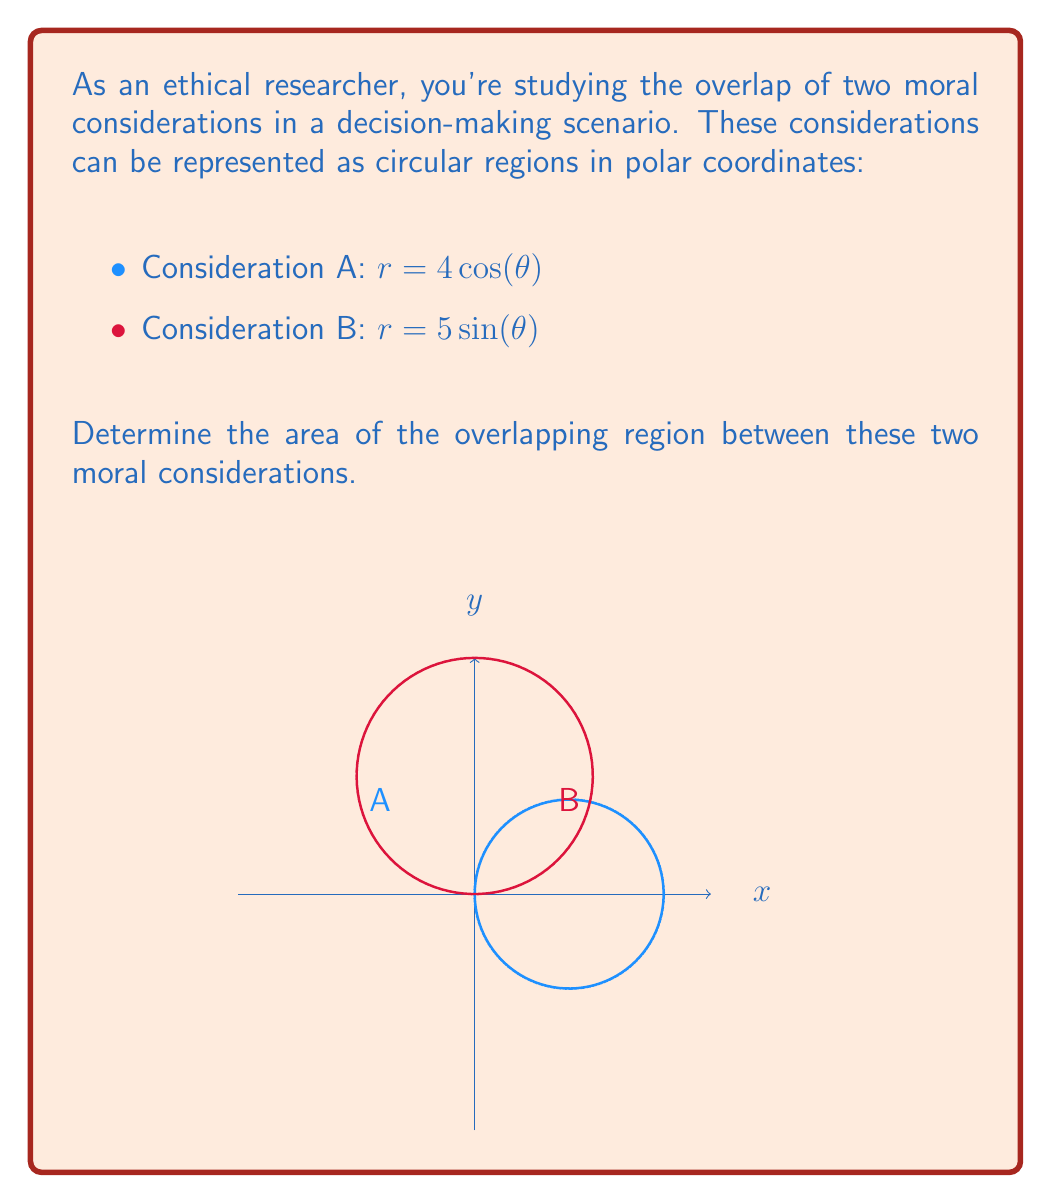Can you solve this math problem? To solve this problem, we'll follow these steps:

1) First, we need to find the points of intersection between the two curves. We can do this by equating the two equations:

   $4\cos(\theta) = 5\sin(\theta)$

2) Dividing both sides by $\cos(\theta)$:

   $4 = 5\tan(\theta)$

3) Solving for $\theta$:

   $\theta = \arctan(\frac{4}{5}) \approx 0.6747$ radians

4) Due to symmetry, the other intersection point is at $\pi - 0.6747 \approx 2.4669$ radians

5) The area of the overlapping region can be calculated using the formula:

   $A = \frac{1}{2}\int_{\theta_1}^{\theta_2} [r_2^2(\theta) - r_1^2(\theta)] d\theta$

   Where $r_2(\theta)$ is the larger radius and $r_1(\theta)$ is the smaller radius in the overlapping region.

6) In our case:

   $A = \frac{1}{2}\int_{0.6747}^{2.4669} [(5\sin(\theta))^2 - (4\cos(\theta))^2] d\theta$

7) Expanding:

   $A = \frac{1}{2}\int_{0.6747}^{2.4669} [25\sin^2(\theta) - 16\cos^2(\theta)] d\theta$

8) This integral can be solved using trigonometric identities and integration techniques:

   $A = \frac{1}{2}[12.5(\theta - \frac{1}{2}\sin(2\theta)) - 8(\theta + \frac{1}{2}\sin(2\theta))]_{0.6747}^{2.4669}$

9) Evaluating the integral:

   $A \approx 9.4247$ square units
Answer: $9.4247$ square units 